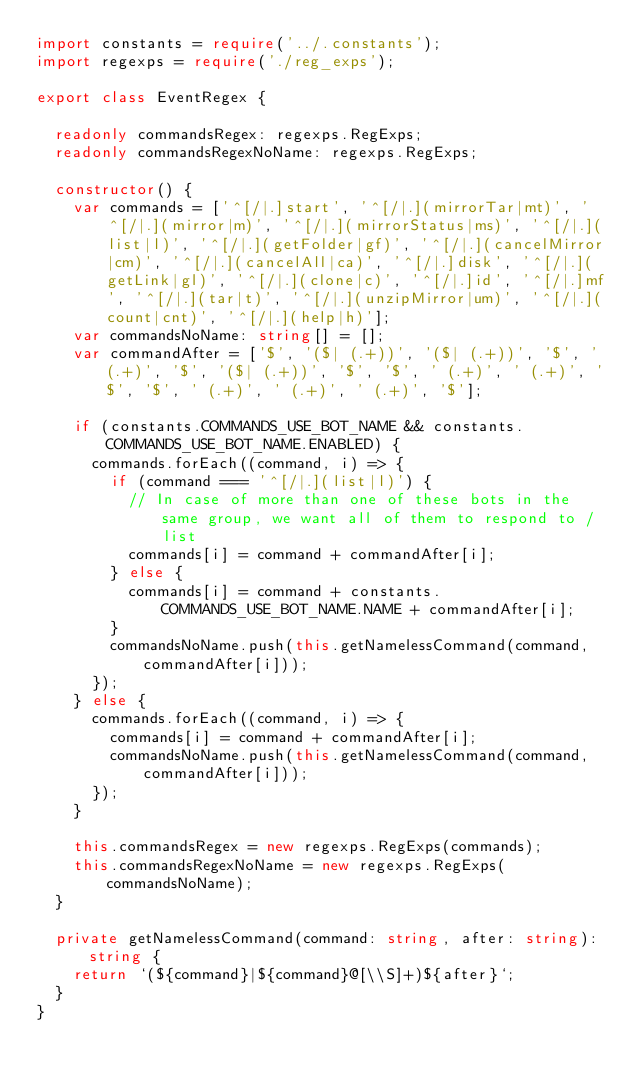<code> <loc_0><loc_0><loc_500><loc_500><_TypeScript_>import constants = require('../.constants');
import regexps = require('./reg_exps');

export class EventRegex {

  readonly commandsRegex: regexps.RegExps;
  readonly commandsRegexNoName: regexps.RegExps;

  constructor() {
    var commands = ['^[/|.]start', '^[/|.](mirrorTar|mt)', '^[/|.](mirror|m)', '^[/|.](mirrorStatus|ms)', '^[/|.](list|l)', '^[/|.](getFolder|gf)', '^[/|.](cancelMirror|cm)', '^[/|.](cancelAll|ca)', '^[/|.]disk', '^[/|.](getLink|gl)', '^[/|.](clone|c)', '^[/|.]id', '^[/|.]mf', '^[/|.](tar|t)', '^[/|.](unzipMirror|um)', '^[/|.](count|cnt)', '^[/|.](help|h)'];
    var commandsNoName: string[] = [];
    var commandAfter = ['$', '($| (.+))', '($| (.+))', '$', ' (.+)', '$', '($| (.+))', '$', '$', ' (.+)', ' (.+)', '$', '$', ' (.+)', ' (.+)', ' (.+)', '$'];

    if (constants.COMMANDS_USE_BOT_NAME && constants.COMMANDS_USE_BOT_NAME.ENABLED) {
      commands.forEach((command, i) => {
        if (command === '^[/|.](list|l)') {
          // In case of more than one of these bots in the same group, we want all of them to respond to /list
          commands[i] = command + commandAfter[i];
        } else {
          commands[i] = command + constants.COMMANDS_USE_BOT_NAME.NAME + commandAfter[i];
        }
        commandsNoName.push(this.getNamelessCommand(command, commandAfter[i]));
      });
    } else {
      commands.forEach((command, i) => {
        commands[i] = command + commandAfter[i];
        commandsNoName.push(this.getNamelessCommand(command, commandAfter[i]));
      });
    }

    this.commandsRegex = new regexps.RegExps(commands);
    this.commandsRegexNoName = new regexps.RegExps(commandsNoName);
  }

  private getNamelessCommand(command: string, after: string): string {
    return `(${command}|${command}@[\\S]+)${after}`;
  }
}</code> 